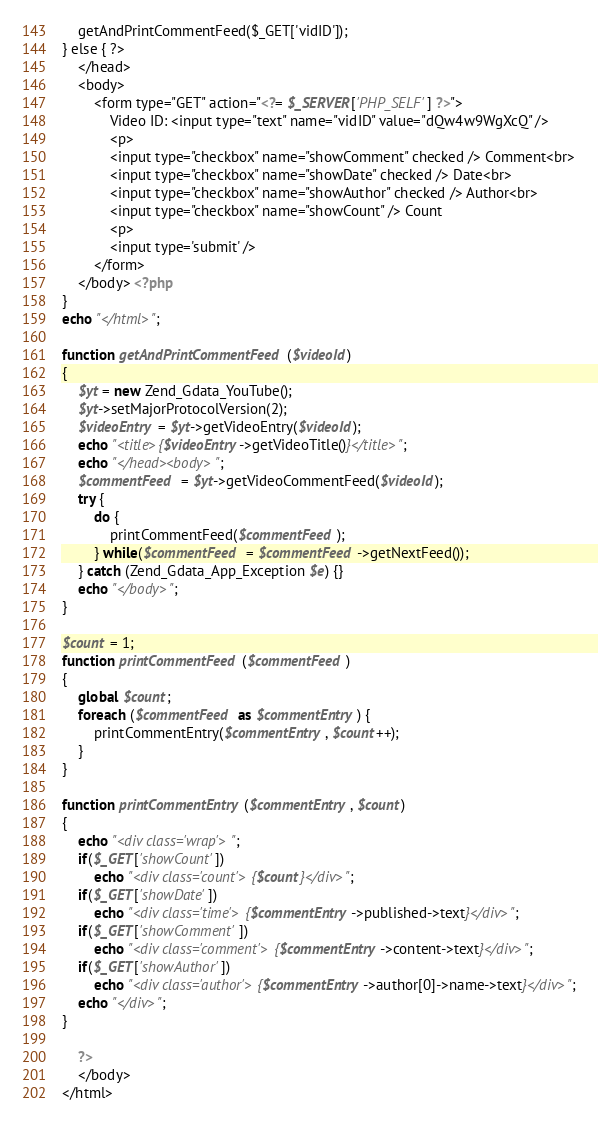Convert code to text. <code><loc_0><loc_0><loc_500><loc_500><_PHP_>	getAndPrintCommentFeed($_GET['vidID']);
} else { ?>
	</head>
	<body>
		<form type="GET" action="<?= $_SERVER['PHP_SELF'] ?>">
			Video ID: <input type="text" name="vidID" value="dQw4w9WgXcQ" />
			<p>
			<input type="checkbox" name="showComment" checked /> Comment<br>
			<input type="checkbox" name="showDate" checked /> Date<br>
			<input type="checkbox" name="showAuthor" checked /> Author<br>
			<input type="checkbox" name="showCount" /> Count
			<p>
			<input type='submit' />
		</form> 
	</body> <?php
}
echo "</html>";

function getAndPrintCommentFeed($videoId)
{
	$yt = new Zend_Gdata_YouTube();
	$yt->setMajorProtocolVersion(2);
	$videoEntry = $yt->getVideoEntry($videoId);
	echo "<title>{$videoEntry->getVideoTitle()}</title>";
	echo "</head><body>";
	$commentFeed = $yt->getVideoCommentFeed($videoId);
	try {
		do {
			printCommentFeed($commentFeed);
		} while($commentFeed = $commentFeed->getNextFeed());
	} catch (Zend_Gdata_App_Exception $e) {}
	echo "</body>";
}

$count = 1;
function printCommentFeed($commentFeed) 
{
	global $count;
	foreach ($commentFeed as $commentEntry) {
		printCommentEntry($commentEntry, $count++);
	}
}

function printCommentEntry($commentEntry, $count) 
{
	echo "<div class='wrap'>";
	if($_GET['showCount'])
		echo "<div class='count'>{$count}</div>";
	if($_GET['showDate'])
		echo "<div class='time'>{$commentEntry->published->text}</div>";
	if($_GET['showComment'])
		echo "<div class='comment'>{$commentEntry->content->text}</div>";
	if($_GET['showAuthor'])
		echo "<div class='author'>{$commentEntry->author[0]->name->text}</div>";
	echo "</div>";
}

	?>
	</body>
</html></code> 